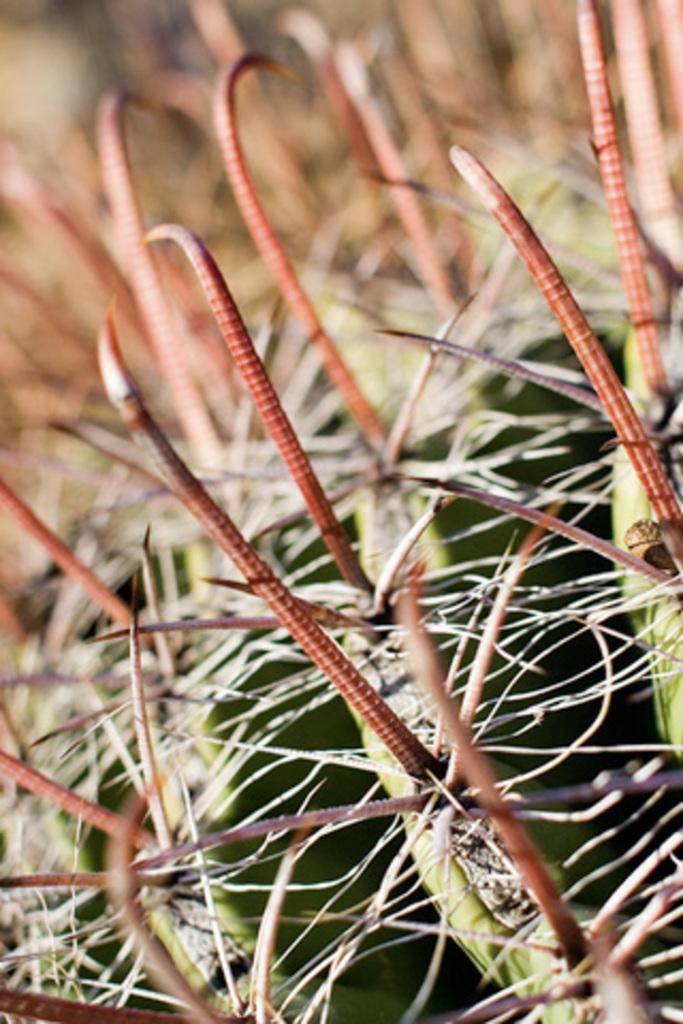Could you give a brief overview of what you see in this image? In this image we can see a plant. 